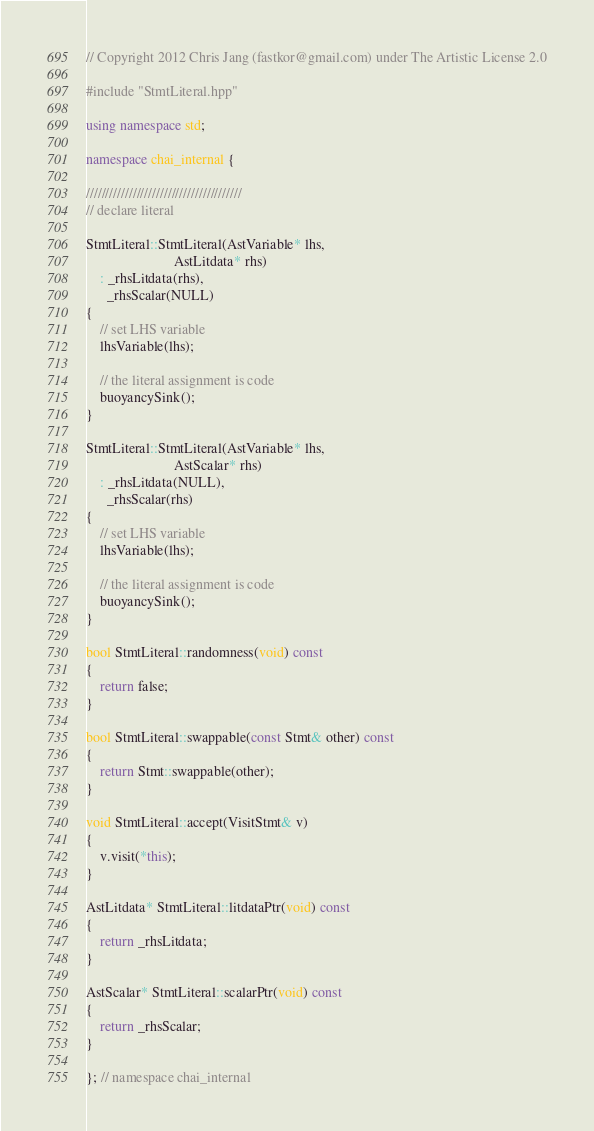Convert code to text. <code><loc_0><loc_0><loc_500><loc_500><_C++_>// Copyright 2012 Chris Jang (fastkor@gmail.com) under The Artistic License 2.0

#include "StmtLiteral.hpp"

using namespace std;

namespace chai_internal {

////////////////////////////////////////
// declare literal

StmtLiteral::StmtLiteral(AstVariable* lhs,
                         AstLitdata* rhs)
    : _rhsLitdata(rhs),
      _rhsScalar(NULL)
{
    // set LHS variable
    lhsVariable(lhs);

    // the literal assignment is code
    buoyancySink();
}

StmtLiteral::StmtLiteral(AstVariable* lhs,
                         AstScalar* rhs)
    : _rhsLitdata(NULL),
      _rhsScalar(rhs)
{
    // set LHS variable
    lhsVariable(lhs);

    // the literal assignment is code
    buoyancySink();
}

bool StmtLiteral::randomness(void) const
{
    return false;
}

bool StmtLiteral::swappable(const Stmt& other) const
{
    return Stmt::swappable(other);
}

void StmtLiteral::accept(VisitStmt& v)
{
    v.visit(*this);
}

AstLitdata* StmtLiteral::litdataPtr(void) const
{
    return _rhsLitdata;
}

AstScalar* StmtLiteral::scalarPtr(void) const
{
    return _rhsScalar;
}

}; // namespace chai_internal
</code> 